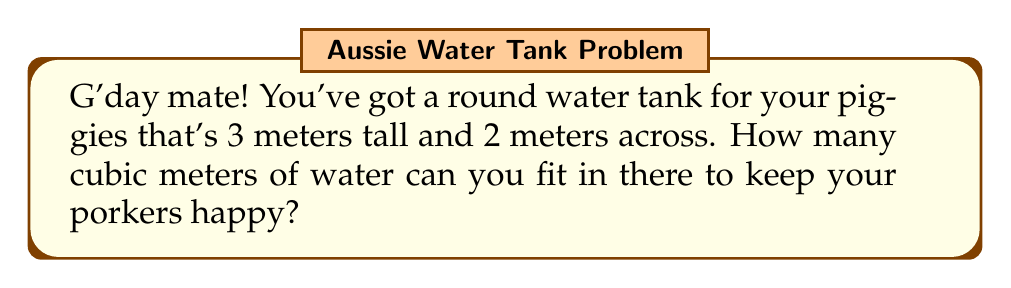Solve this math problem. Alright, let's break this down nice and simple:

1) Our tank is like a big tin can. To find out how much water it holds, we need to work out its volume.

2) The formula for the volume of a cylinder (our tin can shape) is:
   $$V = \pi r^2 h$$
   Where $V$ is volume, $r$ is the radius (half the width), and $h$ is the height.

3) We know:
   - The tank is 3 meters tall, so $h = 3$
   - It's 2 meters across, so the radius $r = 1$ (half of 2)

4) Let's plug these numbers into our formula:
   $$V = \pi \times 1^2 \times 3$$

5) Simplify:
   $$V = \pi \times 1 \times 3 = 3\pi$$

6) If we want a number instead of $\pi$, we can use 3.14 for $\pi$:
   $$V \approx 3 \times 3.14 = 9.42$$

So, your tank can hold about 9.42 cubic meters of water.
Answer: $3\pi$ cubic meters (or approximately 9.42 cubic meters) 